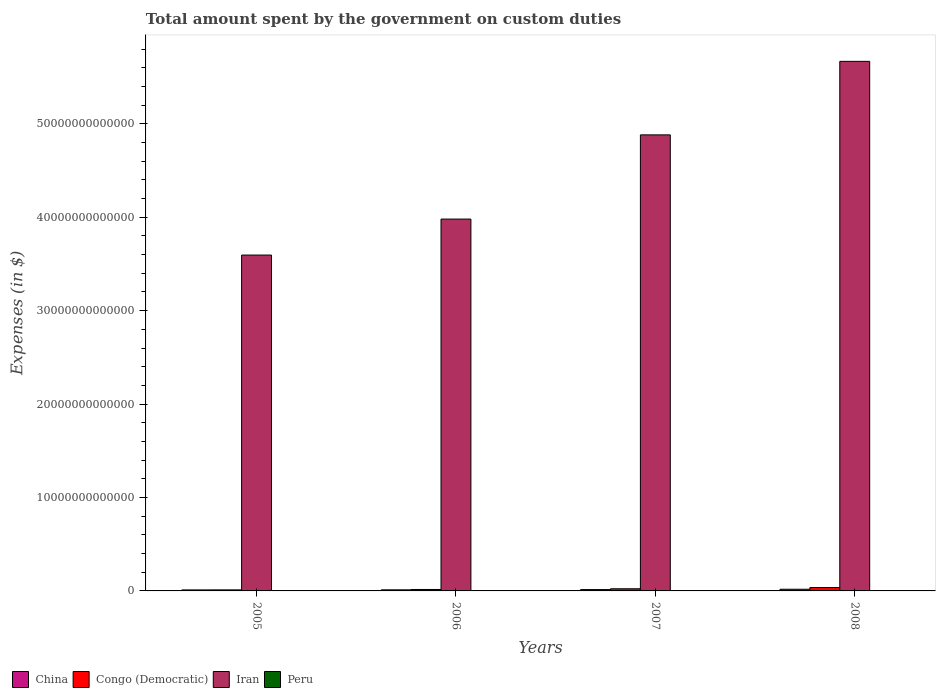How many different coloured bars are there?
Provide a succinct answer. 4. How many bars are there on the 1st tick from the left?
Provide a succinct answer. 4. What is the label of the 4th group of bars from the left?
Your answer should be very brief. 2008. In how many cases, is the number of bars for a given year not equal to the number of legend labels?
Give a very brief answer. 0. What is the amount spent on custom duties by the government in Congo (Democratic) in 2006?
Provide a succinct answer. 1.54e+11. Across all years, what is the maximum amount spent on custom duties by the government in Peru?
Provide a short and direct response. 2.64e+09. Across all years, what is the minimum amount spent on custom duties by the government in Iran?
Provide a short and direct response. 3.60e+13. What is the total amount spent on custom duties by the government in Peru in the graph?
Your answer should be very brief. 8.52e+09. What is the difference between the amount spent on custom duties by the government in China in 2006 and that in 2007?
Your answer should be compact. -2.93e+1. What is the difference between the amount spent on custom duties by the government in Peru in 2007 and the amount spent on custom duties by the government in Congo (Democratic) in 2006?
Offer a terse response. -1.52e+11. What is the average amount spent on custom duties by the government in Iran per year?
Make the answer very short. 4.53e+13. In the year 2007, what is the difference between the amount spent on custom duties by the government in Congo (Democratic) and amount spent on custom duties by the government in China?
Ensure brevity in your answer.  8.55e+1. What is the ratio of the amount spent on custom duties by the government in China in 2005 to that in 2007?
Provide a short and direct response. 0.74. Is the amount spent on custom duties by the government in Peru in 2005 less than that in 2008?
Provide a succinct answer. No. Is the difference between the amount spent on custom duties by the government in Congo (Democratic) in 2005 and 2006 greater than the difference between the amount spent on custom duties by the government in China in 2005 and 2006?
Your answer should be compact. No. What is the difference between the highest and the second highest amount spent on custom duties by the government in Iran?
Your response must be concise. 7.87e+12. What is the difference between the highest and the lowest amount spent on custom duties by the government in Iran?
Keep it short and to the point. 2.07e+13. Is it the case that in every year, the sum of the amount spent on custom duties by the government in China and amount spent on custom duties by the government in Iran is greater than the sum of amount spent on custom duties by the government in Peru and amount spent on custom duties by the government in Congo (Democratic)?
Your response must be concise. Yes. What does the 1st bar from the left in 2008 represents?
Provide a short and direct response. China. What does the 3rd bar from the right in 2008 represents?
Provide a succinct answer. Congo (Democratic). Is it the case that in every year, the sum of the amount spent on custom duties by the government in Iran and amount spent on custom duties by the government in China is greater than the amount spent on custom duties by the government in Peru?
Ensure brevity in your answer.  Yes. What is the difference between two consecutive major ticks on the Y-axis?
Your answer should be very brief. 1.00e+13. Are the values on the major ticks of Y-axis written in scientific E-notation?
Provide a succinct answer. No. How many legend labels are there?
Offer a very short reply. 4. How are the legend labels stacked?
Your response must be concise. Horizontal. What is the title of the graph?
Make the answer very short. Total amount spent by the government on custom duties. What is the label or title of the X-axis?
Offer a terse response. Years. What is the label or title of the Y-axis?
Provide a succinct answer. Expenses (in $). What is the Expenses (in $) of China in 2005?
Make the answer very short. 1.08e+11. What is the Expenses (in $) of Congo (Democratic) in 2005?
Your answer should be compact. 1.10e+11. What is the Expenses (in $) of Iran in 2005?
Provide a succinct answer. 3.60e+13. What is the Expenses (in $) in Peru in 2005?
Offer a very short reply. 2.64e+09. What is the Expenses (in $) in China in 2006?
Provide a succinct answer. 1.16e+11. What is the Expenses (in $) of Congo (Democratic) in 2006?
Make the answer very short. 1.54e+11. What is the Expenses (in $) of Iran in 2006?
Keep it short and to the point. 3.98e+13. What is the Expenses (in $) of Peru in 2006?
Your answer should be very brief. 2.38e+09. What is the Expenses (in $) in China in 2007?
Provide a short and direct response. 1.45e+11. What is the Expenses (in $) of Congo (Democratic) in 2007?
Give a very brief answer. 2.31e+11. What is the Expenses (in $) in Iran in 2007?
Offer a very short reply. 4.88e+13. What is the Expenses (in $) of Peru in 2007?
Ensure brevity in your answer.  1.60e+09. What is the Expenses (in $) of China in 2008?
Your answer should be very brief. 1.79e+11. What is the Expenses (in $) of Congo (Democratic) in 2008?
Ensure brevity in your answer.  3.60e+11. What is the Expenses (in $) of Iran in 2008?
Give a very brief answer. 5.67e+13. What is the Expenses (in $) of Peru in 2008?
Ensure brevity in your answer.  1.91e+09. Across all years, what is the maximum Expenses (in $) in China?
Offer a terse response. 1.79e+11. Across all years, what is the maximum Expenses (in $) in Congo (Democratic)?
Provide a short and direct response. 3.60e+11. Across all years, what is the maximum Expenses (in $) of Iran?
Provide a short and direct response. 5.67e+13. Across all years, what is the maximum Expenses (in $) of Peru?
Keep it short and to the point. 2.64e+09. Across all years, what is the minimum Expenses (in $) of China?
Offer a terse response. 1.08e+11. Across all years, what is the minimum Expenses (in $) in Congo (Democratic)?
Your answer should be compact. 1.10e+11. Across all years, what is the minimum Expenses (in $) of Iran?
Provide a short and direct response. 3.60e+13. Across all years, what is the minimum Expenses (in $) in Peru?
Offer a terse response. 1.60e+09. What is the total Expenses (in $) in China in the graph?
Make the answer very short. 5.48e+11. What is the total Expenses (in $) in Congo (Democratic) in the graph?
Make the answer very short. 8.55e+11. What is the total Expenses (in $) in Iran in the graph?
Your answer should be very brief. 1.81e+14. What is the total Expenses (in $) in Peru in the graph?
Ensure brevity in your answer.  8.52e+09. What is the difference between the Expenses (in $) in China in 2005 and that in 2006?
Provide a succinct answer. -7.75e+09. What is the difference between the Expenses (in $) of Congo (Democratic) in 2005 and that in 2006?
Make the answer very short. -4.36e+1. What is the difference between the Expenses (in $) in Iran in 2005 and that in 2006?
Provide a succinct answer. -3.85e+12. What is the difference between the Expenses (in $) of Peru in 2005 and that in 2006?
Give a very brief answer. 2.62e+08. What is the difference between the Expenses (in $) of China in 2005 and that in 2007?
Keep it short and to the point. -3.71e+1. What is the difference between the Expenses (in $) of Congo (Democratic) in 2005 and that in 2007?
Ensure brevity in your answer.  -1.20e+11. What is the difference between the Expenses (in $) in Iran in 2005 and that in 2007?
Your answer should be very brief. -1.29e+13. What is the difference between the Expenses (in $) in Peru in 2005 and that in 2007?
Give a very brief answer. 1.04e+09. What is the difference between the Expenses (in $) of China in 2005 and that in 2008?
Offer a terse response. -7.10e+1. What is the difference between the Expenses (in $) of Congo (Democratic) in 2005 and that in 2008?
Offer a very short reply. -2.50e+11. What is the difference between the Expenses (in $) of Iran in 2005 and that in 2008?
Provide a short and direct response. -2.07e+13. What is the difference between the Expenses (in $) of Peru in 2005 and that in 2008?
Your answer should be compact. 7.28e+08. What is the difference between the Expenses (in $) of China in 2006 and that in 2007?
Keep it short and to the point. -2.93e+1. What is the difference between the Expenses (in $) of Congo (Democratic) in 2006 and that in 2007?
Ensure brevity in your answer.  -7.66e+1. What is the difference between the Expenses (in $) in Iran in 2006 and that in 2007?
Your answer should be very brief. -9.01e+12. What is the difference between the Expenses (in $) of Peru in 2006 and that in 2007?
Provide a short and direct response. 7.77e+08. What is the difference between the Expenses (in $) in China in 2006 and that in 2008?
Offer a terse response. -6.33e+1. What is the difference between the Expenses (in $) in Congo (Democratic) in 2006 and that in 2008?
Give a very brief answer. -2.06e+11. What is the difference between the Expenses (in $) of Iran in 2006 and that in 2008?
Provide a succinct answer. -1.69e+13. What is the difference between the Expenses (in $) in Peru in 2006 and that in 2008?
Your response must be concise. 4.66e+08. What is the difference between the Expenses (in $) of China in 2007 and that in 2008?
Make the answer very short. -3.39e+1. What is the difference between the Expenses (in $) of Congo (Democratic) in 2007 and that in 2008?
Your answer should be very brief. -1.30e+11. What is the difference between the Expenses (in $) of Iran in 2007 and that in 2008?
Offer a very short reply. -7.87e+12. What is the difference between the Expenses (in $) in Peru in 2007 and that in 2008?
Provide a short and direct response. -3.12e+08. What is the difference between the Expenses (in $) of China in 2005 and the Expenses (in $) of Congo (Democratic) in 2006?
Make the answer very short. -4.60e+1. What is the difference between the Expenses (in $) in China in 2005 and the Expenses (in $) in Iran in 2006?
Keep it short and to the point. -3.97e+13. What is the difference between the Expenses (in $) of China in 2005 and the Expenses (in $) of Peru in 2006?
Your answer should be compact. 1.06e+11. What is the difference between the Expenses (in $) of Congo (Democratic) in 2005 and the Expenses (in $) of Iran in 2006?
Ensure brevity in your answer.  -3.97e+13. What is the difference between the Expenses (in $) of Congo (Democratic) in 2005 and the Expenses (in $) of Peru in 2006?
Offer a very short reply. 1.08e+11. What is the difference between the Expenses (in $) in Iran in 2005 and the Expenses (in $) in Peru in 2006?
Offer a very short reply. 3.60e+13. What is the difference between the Expenses (in $) of China in 2005 and the Expenses (in $) of Congo (Democratic) in 2007?
Offer a terse response. -1.23e+11. What is the difference between the Expenses (in $) of China in 2005 and the Expenses (in $) of Iran in 2007?
Offer a terse response. -4.87e+13. What is the difference between the Expenses (in $) in China in 2005 and the Expenses (in $) in Peru in 2007?
Make the answer very short. 1.06e+11. What is the difference between the Expenses (in $) in Congo (Democratic) in 2005 and the Expenses (in $) in Iran in 2007?
Keep it short and to the point. -4.87e+13. What is the difference between the Expenses (in $) of Congo (Democratic) in 2005 and the Expenses (in $) of Peru in 2007?
Your answer should be very brief. 1.09e+11. What is the difference between the Expenses (in $) of Iran in 2005 and the Expenses (in $) of Peru in 2007?
Provide a short and direct response. 3.60e+13. What is the difference between the Expenses (in $) of China in 2005 and the Expenses (in $) of Congo (Democratic) in 2008?
Give a very brief answer. -2.52e+11. What is the difference between the Expenses (in $) in China in 2005 and the Expenses (in $) in Iran in 2008?
Your answer should be very brief. -5.66e+13. What is the difference between the Expenses (in $) of China in 2005 and the Expenses (in $) of Peru in 2008?
Your answer should be very brief. 1.06e+11. What is the difference between the Expenses (in $) in Congo (Democratic) in 2005 and the Expenses (in $) in Iran in 2008?
Offer a very short reply. -5.66e+13. What is the difference between the Expenses (in $) in Congo (Democratic) in 2005 and the Expenses (in $) in Peru in 2008?
Make the answer very short. 1.08e+11. What is the difference between the Expenses (in $) in Iran in 2005 and the Expenses (in $) in Peru in 2008?
Your answer should be very brief. 3.60e+13. What is the difference between the Expenses (in $) of China in 2006 and the Expenses (in $) of Congo (Democratic) in 2007?
Ensure brevity in your answer.  -1.15e+11. What is the difference between the Expenses (in $) in China in 2006 and the Expenses (in $) in Iran in 2007?
Provide a succinct answer. -4.87e+13. What is the difference between the Expenses (in $) of China in 2006 and the Expenses (in $) of Peru in 2007?
Provide a short and direct response. 1.14e+11. What is the difference between the Expenses (in $) of Congo (Democratic) in 2006 and the Expenses (in $) of Iran in 2007?
Provide a short and direct response. -4.87e+13. What is the difference between the Expenses (in $) of Congo (Democratic) in 2006 and the Expenses (in $) of Peru in 2007?
Offer a very short reply. 1.52e+11. What is the difference between the Expenses (in $) of Iran in 2006 and the Expenses (in $) of Peru in 2007?
Your answer should be very brief. 3.98e+13. What is the difference between the Expenses (in $) of China in 2006 and the Expenses (in $) of Congo (Democratic) in 2008?
Offer a very short reply. -2.44e+11. What is the difference between the Expenses (in $) of China in 2006 and the Expenses (in $) of Iran in 2008?
Keep it short and to the point. -5.66e+13. What is the difference between the Expenses (in $) in China in 2006 and the Expenses (in $) in Peru in 2008?
Provide a short and direct response. 1.14e+11. What is the difference between the Expenses (in $) of Congo (Democratic) in 2006 and the Expenses (in $) of Iran in 2008?
Provide a succinct answer. -5.65e+13. What is the difference between the Expenses (in $) in Congo (Democratic) in 2006 and the Expenses (in $) in Peru in 2008?
Provide a short and direct response. 1.52e+11. What is the difference between the Expenses (in $) in Iran in 2006 and the Expenses (in $) in Peru in 2008?
Give a very brief answer. 3.98e+13. What is the difference between the Expenses (in $) of China in 2007 and the Expenses (in $) of Congo (Democratic) in 2008?
Provide a short and direct response. -2.15e+11. What is the difference between the Expenses (in $) in China in 2007 and the Expenses (in $) in Iran in 2008?
Provide a succinct answer. -5.65e+13. What is the difference between the Expenses (in $) of China in 2007 and the Expenses (in $) of Peru in 2008?
Your answer should be very brief. 1.43e+11. What is the difference between the Expenses (in $) in Congo (Democratic) in 2007 and the Expenses (in $) in Iran in 2008?
Ensure brevity in your answer.  -5.65e+13. What is the difference between the Expenses (in $) of Congo (Democratic) in 2007 and the Expenses (in $) of Peru in 2008?
Make the answer very short. 2.29e+11. What is the difference between the Expenses (in $) in Iran in 2007 and the Expenses (in $) in Peru in 2008?
Give a very brief answer. 4.88e+13. What is the average Expenses (in $) of China per year?
Offer a terse response. 1.37e+11. What is the average Expenses (in $) of Congo (Democratic) per year?
Provide a short and direct response. 2.14e+11. What is the average Expenses (in $) in Iran per year?
Give a very brief answer. 4.53e+13. What is the average Expenses (in $) in Peru per year?
Your answer should be very brief. 2.13e+09. In the year 2005, what is the difference between the Expenses (in $) of China and Expenses (in $) of Congo (Democratic)?
Your answer should be very brief. -2.41e+09. In the year 2005, what is the difference between the Expenses (in $) in China and Expenses (in $) in Iran?
Your response must be concise. -3.58e+13. In the year 2005, what is the difference between the Expenses (in $) in China and Expenses (in $) in Peru?
Give a very brief answer. 1.05e+11. In the year 2005, what is the difference between the Expenses (in $) of Congo (Democratic) and Expenses (in $) of Iran?
Provide a succinct answer. -3.58e+13. In the year 2005, what is the difference between the Expenses (in $) of Congo (Democratic) and Expenses (in $) of Peru?
Your answer should be very brief. 1.08e+11. In the year 2005, what is the difference between the Expenses (in $) in Iran and Expenses (in $) in Peru?
Offer a terse response. 3.60e+13. In the year 2006, what is the difference between the Expenses (in $) in China and Expenses (in $) in Congo (Democratic)?
Offer a very short reply. -3.83e+1. In the year 2006, what is the difference between the Expenses (in $) in China and Expenses (in $) in Iran?
Ensure brevity in your answer.  -3.97e+13. In the year 2006, what is the difference between the Expenses (in $) of China and Expenses (in $) of Peru?
Make the answer very short. 1.13e+11. In the year 2006, what is the difference between the Expenses (in $) in Congo (Democratic) and Expenses (in $) in Iran?
Provide a short and direct response. -3.97e+13. In the year 2006, what is the difference between the Expenses (in $) in Congo (Democratic) and Expenses (in $) in Peru?
Ensure brevity in your answer.  1.52e+11. In the year 2006, what is the difference between the Expenses (in $) of Iran and Expenses (in $) of Peru?
Provide a succinct answer. 3.98e+13. In the year 2007, what is the difference between the Expenses (in $) in China and Expenses (in $) in Congo (Democratic)?
Provide a short and direct response. -8.55e+1. In the year 2007, what is the difference between the Expenses (in $) in China and Expenses (in $) in Iran?
Your response must be concise. -4.87e+13. In the year 2007, what is the difference between the Expenses (in $) of China and Expenses (in $) of Peru?
Offer a terse response. 1.43e+11. In the year 2007, what is the difference between the Expenses (in $) of Congo (Democratic) and Expenses (in $) of Iran?
Ensure brevity in your answer.  -4.86e+13. In the year 2007, what is the difference between the Expenses (in $) of Congo (Democratic) and Expenses (in $) of Peru?
Provide a succinct answer. 2.29e+11. In the year 2007, what is the difference between the Expenses (in $) of Iran and Expenses (in $) of Peru?
Ensure brevity in your answer.  4.88e+13. In the year 2008, what is the difference between the Expenses (in $) in China and Expenses (in $) in Congo (Democratic)?
Make the answer very short. -1.81e+11. In the year 2008, what is the difference between the Expenses (in $) in China and Expenses (in $) in Iran?
Give a very brief answer. -5.65e+13. In the year 2008, what is the difference between the Expenses (in $) in China and Expenses (in $) in Peru?
Provide a succinct answer. 1.77e+11. In the year 2008, what is the difference between the Expenses (in $) in Congo (Democratic) and Expenses (in $) in Iran?
Offer a terse response. -5.63e+13. In the year 2008, what is the difference between the Expenses (in $) of Congo (Democratic) and Expenses (in $) of Peru?
Offer a very short reply. 3.58e+11. In the year 2008, what is the difference between the Expenses (in $) in Iran and Expenses (in $) in Peru?
Provide a succinct answer. 5.67e+13. What is the ratio of the Expenses (in $) of China in 2005 to that in 2006?
Give a very brief answer. 0.93. What is the ratio of the Expenses (in $) in Congo (Democratic) in 2005 to that in 2006?
Ensure brevity in your answer.  0.72. What is the ratio of the Expenses (in $) in Iran in 2005 to that in 2006?
Your response must be concise. 0.9. What is the ratio of the Expenses (in $) in Peru in 2005 to that in 2006?
Keep it short and to the point. 1.11. What is the ratio of the Expenses (in $) in China in 2005 to that in 2007?
Provide a short and direct response. 0.74. What is the ratio of the Expenses (in $) of Congo (Democratic) in 2005 to that in 2007?
Your response must be concise. 0.48. What is the ratio of the Expenses (in $) in Iran in 2005 to that in 2007?
Offer a very short reply. 0.74. What is the ratio of the Expenses (in $) of Peru in 2005 to that in 2007?
Provide a short and direct response. 1.65. What is the ratio of the Expenses (in $) in China in 2005 to that in 2008?
Give a very brief answer. 0.6. What is the ratio of the Expenses (in $) of Congo (Democratic) in 2005 to that in 2008?
Your answer should be compact. 0.31. What is the ratio of the Expenses (in $) in Iran in 2005 to that in 2008?
Provide a short and direct response. 0.63. What is the ratio of the Expenses (in $) in Peru in 2005 to that in 2008?
Offer a very short reply. 1.38. What is the ratio of the Expenses (in $) in China in 2006 to that in 2007?
Give a very brief answer. 0.8. What is the ratio of the Expenses (in $) in Congo (Democratic) in 2006 to that in 2007?
Make the answer very short. 0.67. What is the ratio of the Expenses (in $) of Iran in 2006 to that in 2007?
Provide a succinct answer. 0.82. What is the ratio of the Expenses (in $) of Peru in 2006 to that in 2007?
Provide a short and direct response. 1.49. What is the ratio of the Expenses (in $) of China in 2006 to that in 2008?
Offer a very short reply. 0.65. What is the ratio of the Expenses (in $) of Congo (Democratic) in 2006 to that in 2008?
Give a very brief answer. 0.43. What is the ratio of the Expenses (in $) of Iran in 2006 to that in 2008?
Keep it short and to the point. 0.7. What is the ratio of the Expenses (in $) of Peru in 2006 to that in 2008?
Your answer should be compact. 1.24. What is the ratio of the Expenses (in $) of China in 2007 to that in 2008?
Provide a succinct answer. 0.81. What is the ratio of the Expenses (in $) of Congo (Democratic) in 2007 to that in 2008?
Make the answer very short. 0.64. What is the ratio of the Expenses (in $) of Iran in 2007 to that in 2008?
Give a very brief answer. 0.86. What is the ratio of the Expenses (in $) in Peru in 2007 to that in 2008?
Provide a succinct answer. 0.84. What is the difference between the highest and the second highest Expenses (in $) in China?
Provide a succinct answer. 3.39e+1. What is the difference between the highest and the second highest Expenses (in $) of Congo (Democratic)?
Your answer should be compact. 1.30e+11. What is the difference between the highest and the second highest Expenses (in $) of Iran?
Make the answer very short. 7.87e+12. What is the difference between the highest and the second highest Expenses (in $) of Peru?
Your answer should be compact. 2.62e+08. What is the difference between the highest and the lowest Expenses (in $) in China?
Your response must be concise. 7.10e+1. What is the difference between the highest and the lowest Expenses (in $) of Congo (Democratic)?
Provide a succinct answer. 2.50e+11. What is the difference between the highest and the lowest Expenses (in $) of Iran?
Offer a terse response. 2.07e+13. What is the difference between the highest and the lowest Expenses (in $) of Peru?
Ensure brevity in your answer.  1.04e+09. 